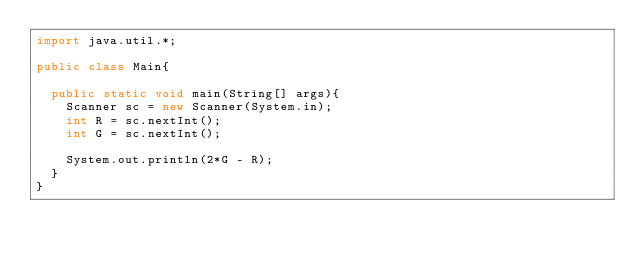<code> <loc_0><loc_0><loc_500><loc_500><_Java_>import java.util.*;

public class Main{

	public static void main(String[] args){
		Scanner sc = new Scanner(System.in);
		int R = sc.nextInt();
		int G = sc.nextInt();
		
		System.out.println(2*G - R);
	}
}</code> 